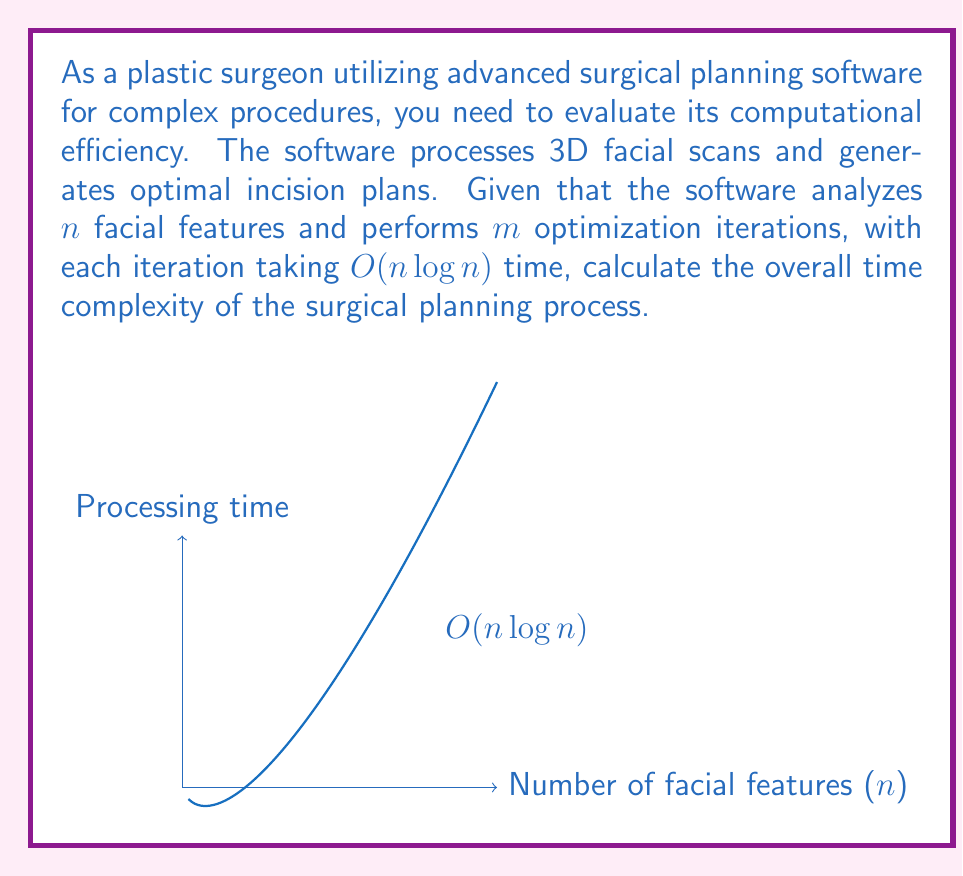Solve this math problem. To calculate the overall time complexity, we need to consider the following steps:

1. The software analyzes $n$ facial features.
2. It performs $m$ optimization iterations.
3. Each iteration takes $O(n \log n)$ time.

Let's break down the process:

1. The time complexity for a single iteration is $O(n \log n)$.
2. This iteration is repeated $m$ times.
3. Therefore, the total time complexity is the product of the number of iterations and the time complexity of each iteration:

   $O(m \cdot n \log n)$

This can be simplified as:

$O(mn \log n)$

The graph in the question illustrates the growth of the $O(n \log n)$ function, which represents the time complexity of a single iteration. The overall complexity $O(mn \log n)$ will grow even faster due to the additional factor $m$.

It's important to note that this time complexity assumes that $m$ is independent of $n$. If $m$ were a function of $n$, the complexity would need to be adjusted accordingly.
Answer: $O(mn \log n)$ 